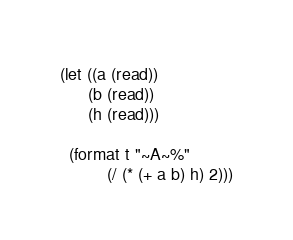<code> <loc_0><loc_0><loc_500><loc_500><_Lisp_>(let ((a (read))
      (b (read))
      (h (read)))

  (format t "~A~%"
          (/ (* (+ a b) h) 2)))
</code> 